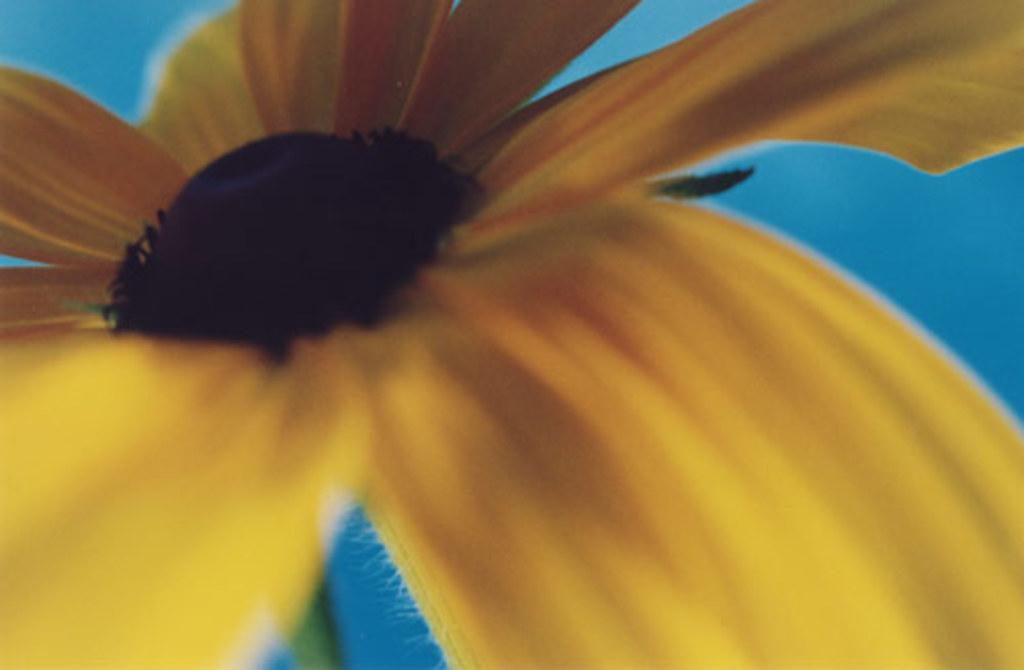What is the focus of the image? The image is a zoomed-in view. What can be seen in the foreground of the image? There is a flower in the foreground of the image. What color is the background of the image? The background of the image is blue in color. How many lizards are sitting on the box in the image? There is no box or lizards present in the image. 